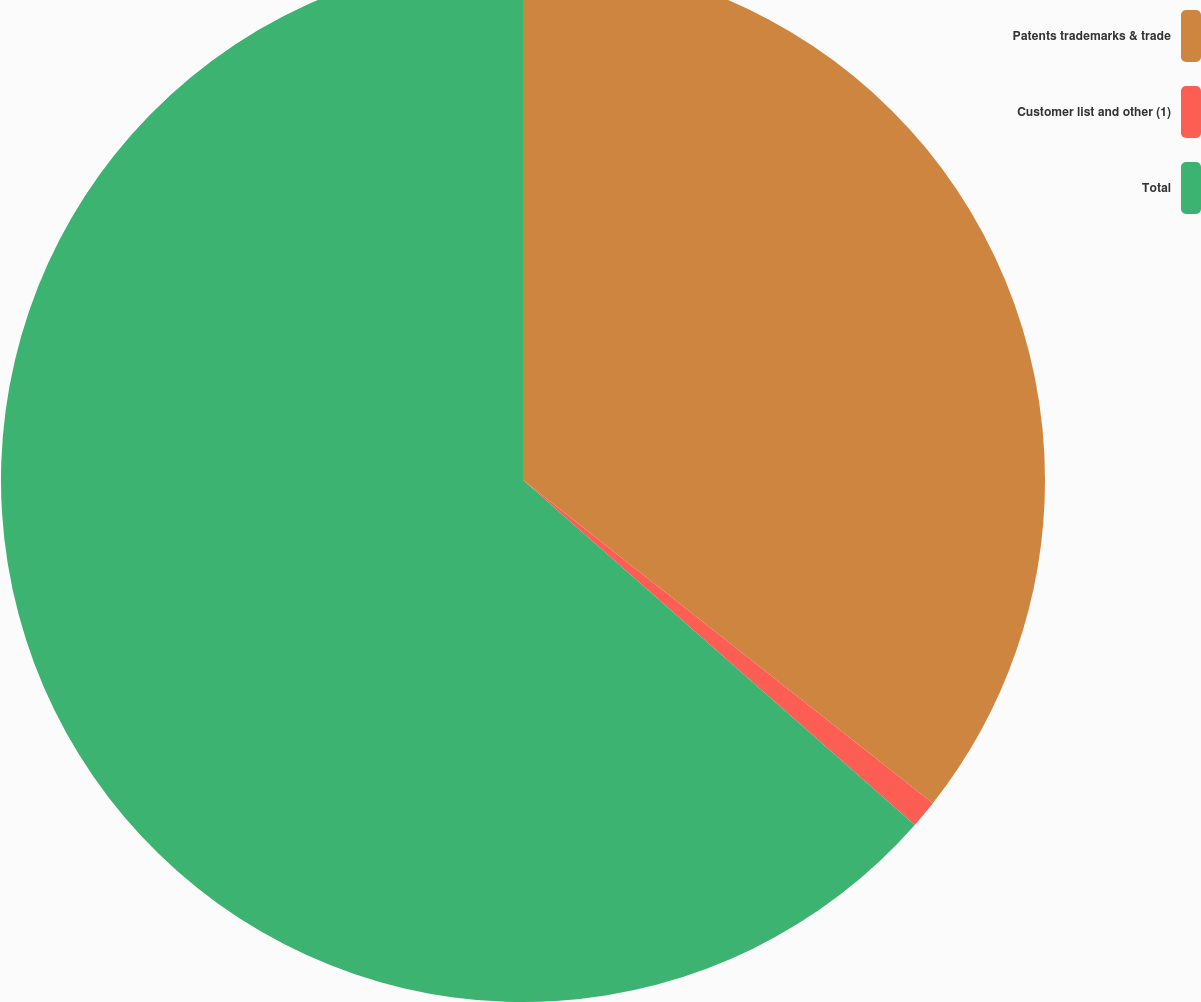Convert chart. <chart><loc_0><loc_0><loc_500><loc_500><pie_chart><fcel>Patents trademarks & trade<fcel>Customer list and other (1)<fcel>Total<nl><fcel>35.63%<fcel>0.86%<fcel>63.51%<nl></chart> 